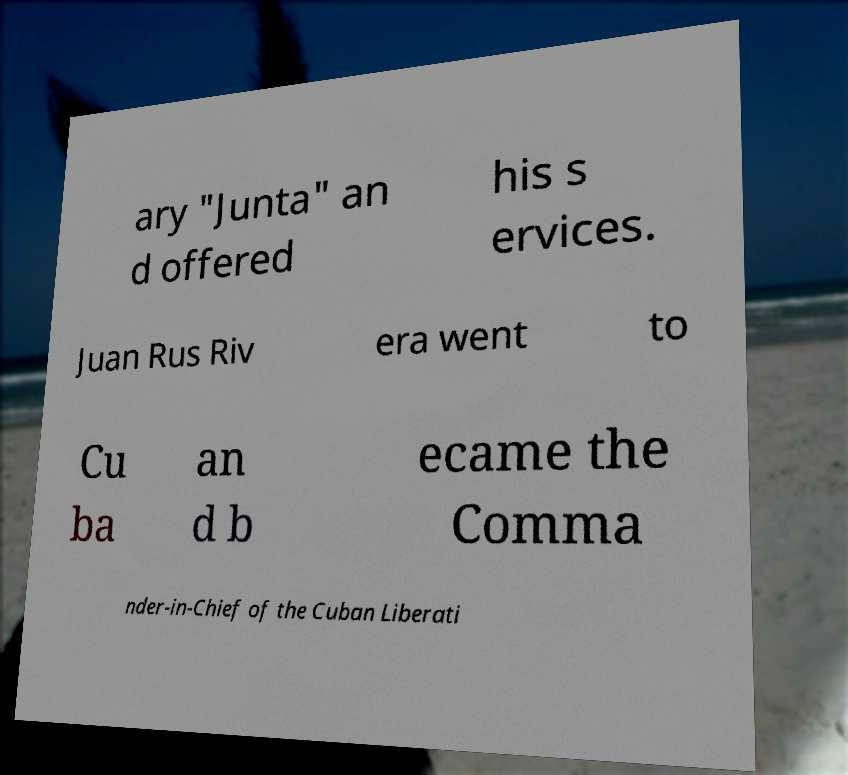Could you extract and type out the text from this image? ary "Junta" an d offered his s ervices. Juan Rus Riv era went to Cu ba an d b ecame the Comma nder-in-Chief of the Cuban Liberati 